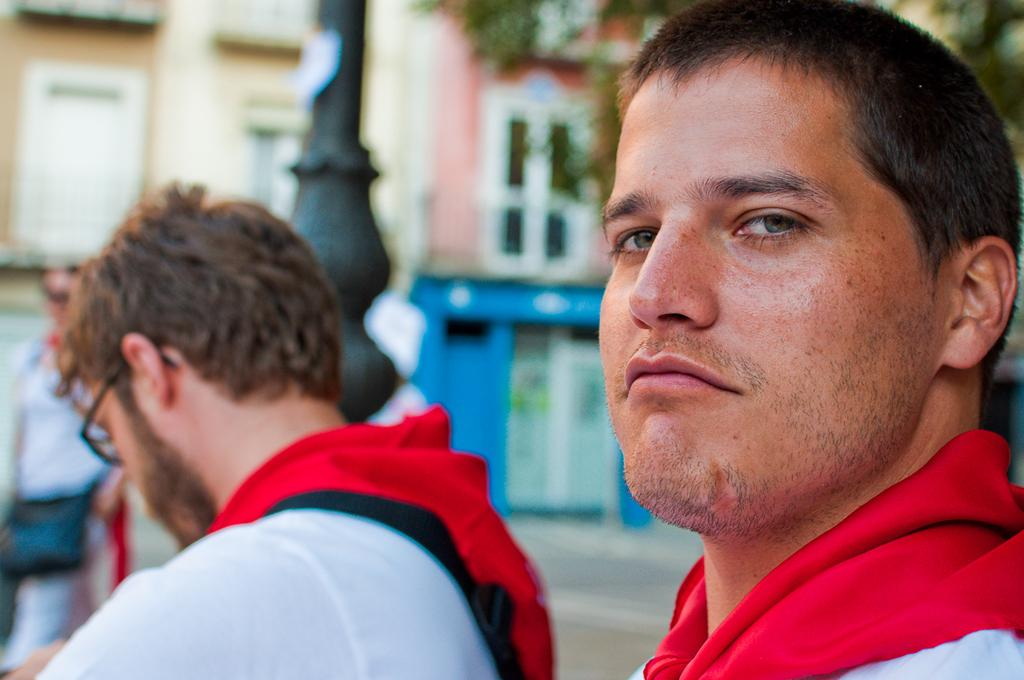How many people are in the image? There are two men in the image. What can be seen in the background of the image? In the background, there is a person, a bag, windows, a wall, and a tree. Can you describe the setting of the image? The image appears to be set indoors, with a wall and windows in the background. What type of ants can be seen crawling on the volleyball in the image? There is no volleyball or ants present in the image. What dish is the cook preparing in the image? There is no cook or dish preparation visible in the image. 